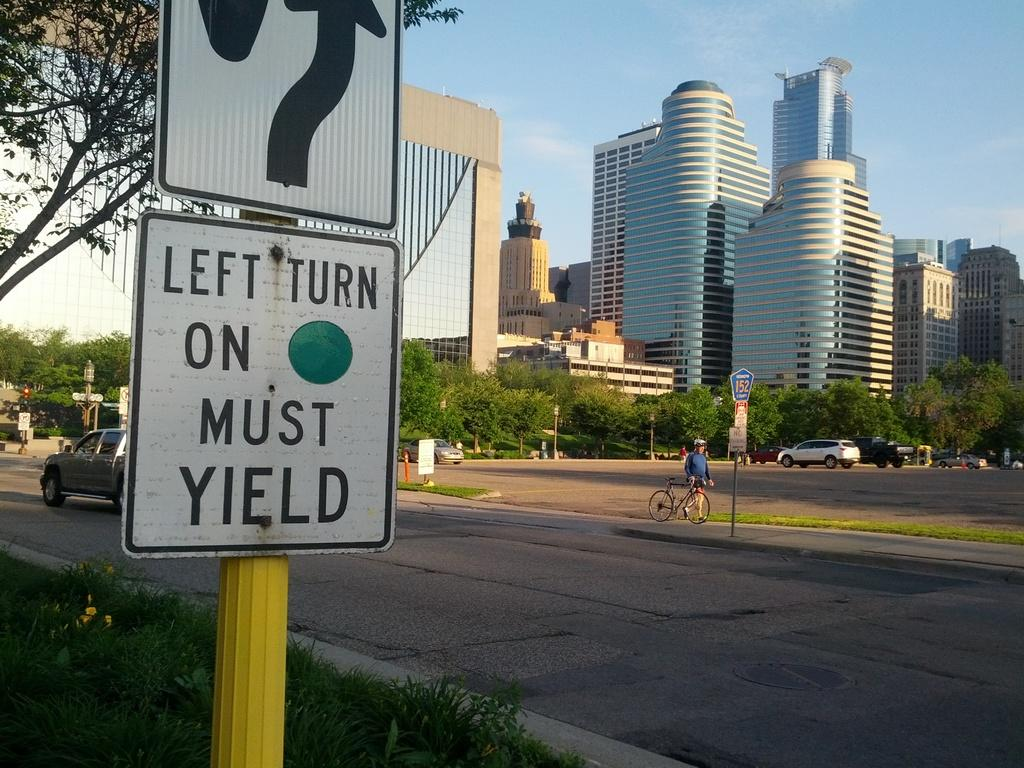<image>
Share a concise interpretation of the image provided. White sign that says "Left Turn on Must Yield" on a yellow pole. 